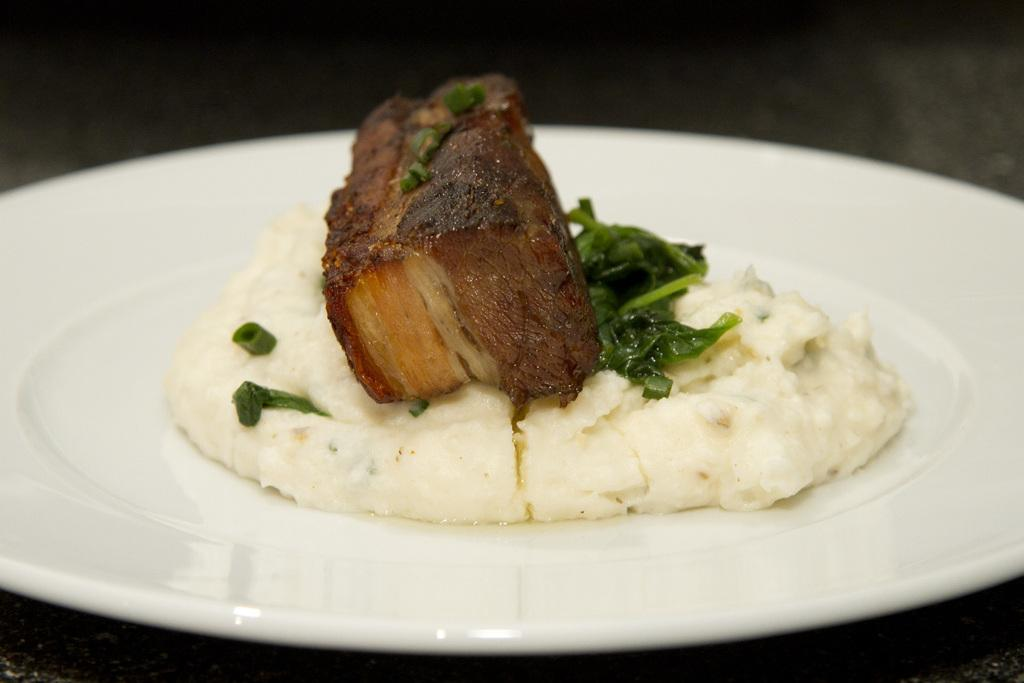What can be seen in the image? There are food items in the image. What is the color of the plate on which the food items are placed? The plate is white in color. What type of earth is depicted in the image? There is no earth depicted in the image; it features food items on a white plate. Is there a locket visible in the image? No, there is no locket present in the image. 